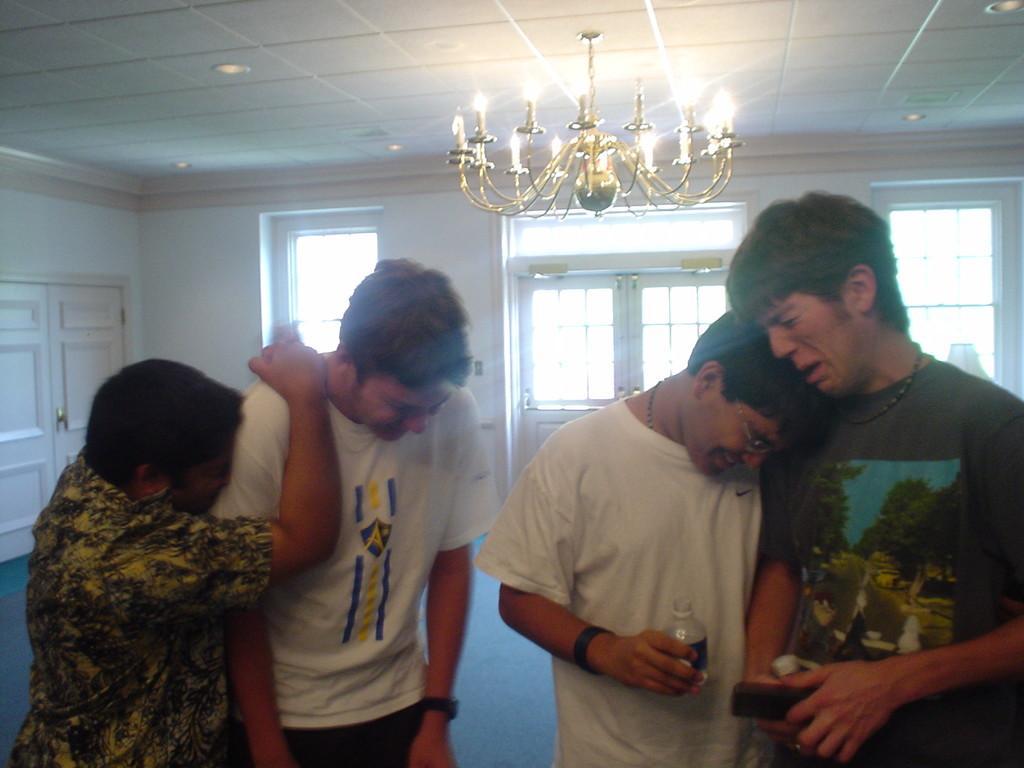How would you summarize this image in a sentence or two? In this image I can see four persons standing. In front the person is wearing white color shirt and holding the bottle. I can also see the chandelier, background I can see few windows and the wall is in white color. 